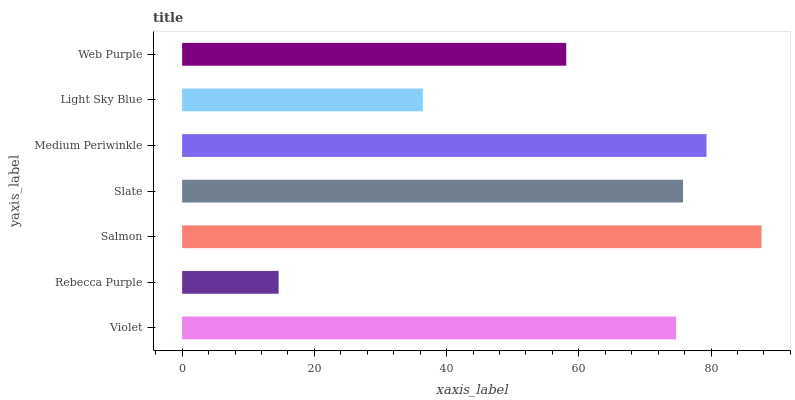Is Rebecca Purple the minimum?
Answer yes or no. Yes. Is Salmon the maximum?
Answer yes or no. Yes. Is Salmon the minimum?
Answer yes or no. No. Is Rebecca Purple the maximum?
Answer yes or no. No. Is Salmon greater than Rebecca Purple?
Answer yes or no. Yes. Is Rebecca Purple less than Salmon?
Answer yes or no. Yes. Is Rebecca Purple greater than Salmon?
Answer yes or no. No. Is Salmon less than Rebecca Purple?
Answer yes or no. No. Is Violet the high median?
Answer yes or no. Yes. Is Violet the low median?
Answer yes or no. Yes. Is Rebecca Purple the high median?
Answer yes or no. No. Is Salmon the low median?
Answer yes or no. No. 